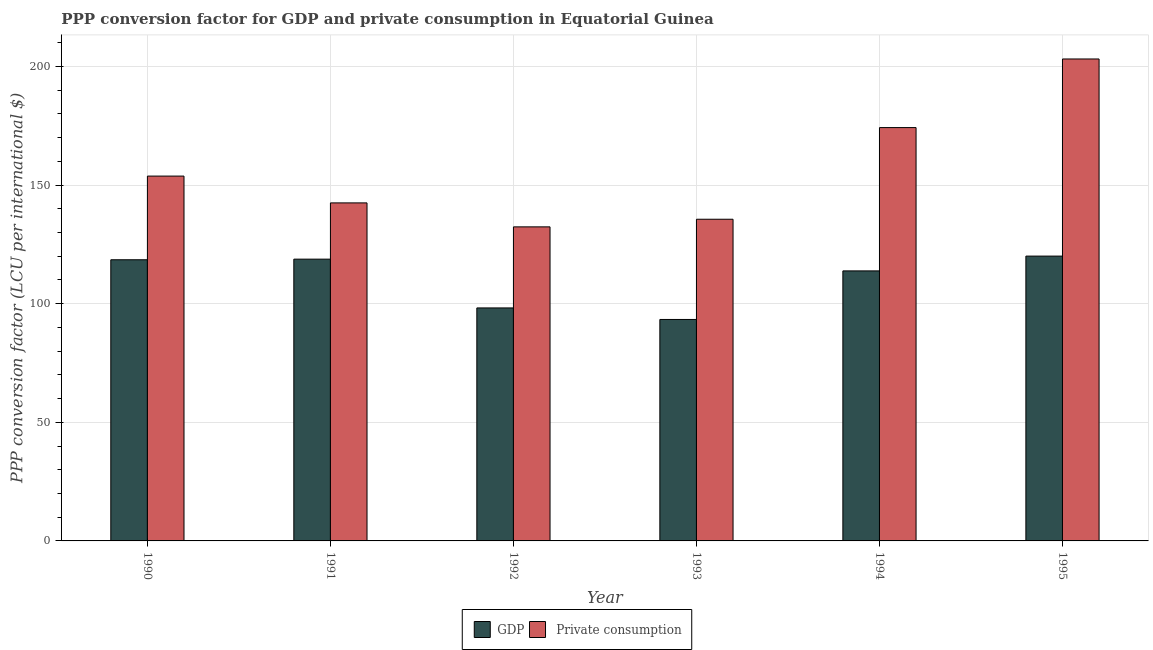How many different coloured bars are there?
Ensure brevity in your answer.  2. How many groups of bars are there?
Provide a short and direct response. 6. Are the number of bars per tick equal to the number of legend labels?
Ensure brevity in your answer.  Yes. How many bars are there on the 2nd tick from the right?
Provide a succinct answer. 2. What is the label of the 4th group of bars from the left?
Provide a succinct answer. 1993. What is the ppp conversion factor for gdp in 1992?
Make the answer very short. 98.22. Across all years, what is the maximum ppp conversion factor for gdp?
Keep it short and to the point. 120.06. Across all years, what is the minimum ppp conversion factor for gdp?
Your response must be concise. 93.35. What is the total ppp conversion factor for gdp in the graph?
Give a very brief answer. 662.74. What is the difference between the ppp conversion factor for private consumption in 1991 and that in 1992?
Provide a succinct answer. 10.11. What is the difference between the ppp conversion factor for private consumption in 1990 and the ppp conversion factor for gdp in 1991?
Your answer should be compact. 11.3. What is the average ppp conversion factor for private consumption per year?
Offer a very short reply. 156.94. In the year 1994, what is the difference between the ppp conversion factor for private consumption and ppp conversion factor for gdp?
Ensure brevity in your answer.  0. What is the ratio of the ppp conversion factor for private consumption in 1990 to that in 1992?
Keep it short and to the point. 1.16. What is the difference between the highest and the second highest ppp conversion factor for gdp?
Keep it short and to the point. 1.29. What is the difference between the highest and the lowest ppp conversion factor for gdp?
Make the answer very short. 26.71. What does the 1st bar from the left in 1992 represents?
Offer a very short reply. GDP. What does the 2nd bar from the right in 1990 represents?
Give a very brief answer. GDP. What is the difference between two consecutive major ticks on the Y-axis?
Offer a very short reply. 50. How many legend labels are there?
Offer a very short reply. 2. How are the legend labels stacked?
Provide a succinct answer. Horizontal. What is the title of the graph?
Provide a short and direct response. PPP conversion factor for GDP and private consumption in Equatorial Guinea. What is the label or title of the Y-axis?
Offer a terse response. PPP conversion factor (LCU per international $). What is the PPP conversion factor (LCU per international $) in GDP in 1990?
Give a very brief answer. 118.52. What is the PPP conversion factor (LCU per international $) in  Private consumption in 1990?
Offer a very short reply. 153.79. What is the PPP conversion factor (LCU per international $) in GDP in 1991?
Make the answer very short. 118.77. What is the PPP conversion factor (LCU per international $) in  Private consumption in 1991?
Your response must be concise. 142.49. What is the PPP conversion factor (LCU per international $) of GDP in 1992?
Offer a terse response. 98.22. What is the PPP conversion factor (LCU per international $) of  Private consumption in 1992?
Offer a very short reply. 132.38. What is the PPP conversion factor (LCU per international $) in GDP in 1993?
Your answer should be compact. 93.35. What is the PPP conversion factor (LCU per international $) of  Private consumption in 1993?
Provide a short and direct response. 135.6. What is the PPP conversion factor (LCU per international $) in GDP in 1994?
Keep it short and to the point. 113.82. What is the PPP conversion factor (LCU per international $) in  Private consumption in 1994?
Keep it short and to the point. 174.23. What is the PPP conversion factor (LCU per international $) of GDP in 1995?
Your answer should be very brief. 120.06. What is the PPP conversion factor (LCU per international $) in  Private consumption in 1995?
Provide a succinct answer. 203.16. Across all years, what is the maximum PPP conversion factor (LCU per international $) of GDP?
Your response must be concise. 120.06. Across all years, what is the maximum PPP conversion factor (LCU per international $) in  Private consumption?
Keep it short and to the point. 203.16. Across all years, what is the minimum PPP conversion factor (LCU per international $) of GDP?
Your response must be concise. 93.35. Across all years, what is the minimum PPP conversion factor (LCU per international $) of  Private consumption?
Provide a short and direct response. 132.38. What is the total PPP conversion factor (LCU per international $) in GDP in the graph?
Offer a very short reply. 662.74. What is the total PPP conversion factor (LCU per international $) of  Private consumption in the graph?
Give a very brief answer. 941.65. What is the difference between the PPP conversion factor (LCU per international $) in GDP in 1990 and that in 1991?
Make the answer very short. -0.26. What is the difference between the PPP conversion factor (LCU per international $) of  Private consumption in 1990 and that in 1991?
Provide a short and direct response. 11.3. What is the difference between the PPP conversion factor (LCU per international $) of GDP in 1990 and that in 1992?
Offer a very short reply. 20.3. What is the difference between the PPP conversion factor (LCU per international $) of  Private consumption in 1990 and that in 1992?
Provide a short and direct response. 21.41. What is the difference between the PPP conversion factor (LCU per international $) in GDP in 1990 and that in 1993?
Your answer should be compact. 25.17. What is the difference between the PPP conversion factor (LCU per international $) of  Private consumption in 1990 and that in 1993?
Your answer should be very brief. 18.19. What is the difference between the PPP conversion factor (LCU per international $) of GDP in 1990 and that in 1994?
Your answer should be compact. 4.69. What is the difference between the PPP conversion factor (LCU per international $) of  Private consumption in 1990 and that in 1994?
Give a very brief answer. -20.44. What is the difference between the PPP conversion factor (LCU per international $) of GDP in 1990 and that in 1995?
Your answer should be compact. -1.54. What is the difference between the PPP conversion factor (LCU per international $) in  Private consumption in 1990 and that in 1995?
Ensure brevity in your answer.  -49.36. What is the difference between the PPP conversion factor (LCU per international $) of GDP in 1991 and that in 1992?
Your answer should be compact. 20.56. What is the difference between the PPP conversion factor (LCU per international $) in  Private consumption in 1991 and that in 1992?
Give a very brief answer. 10.11. What is the difference between the PPP conversion factor (LCU per international $) of GDP in 1991 and that in 1993?
Your answer should be very brief. 25.42. What is the difference between the PPP conversion factor (LCU per international $) in  Private consumption in 1991 and that in 1993?
Your response must be concise. 6.89. What is the difference between the PPP conversion factor (LCU per international $) in GDP in 1991 and that in 1994?
Provide a short and direct response. 4.95. What is the difference between the PPP conversion factor (LCU per international $) in  Private consumption in 1991 and that in 1994?
Provide a short and direct response. -31.74. What is the difference between the PPP conversion factor (LCU per international $) in GDP in 1991 and that in 1995?
Ensure brevity in your answer.  -1.29. What is the difference between the PPP conversion factor (LCU per international $) of  Private consumption in 1991 and that in 1995?
Your answer should be compact. -60.67. What is the difference between the PPP conversion factor (LCU per international $) of GDP in 1992 and that in 1993?
Your response must be concise. 4.87. What is the difference between the PPP conversion factor (LCU per international $) in  Private consumption in 1992 and that in 1993?
Make the answer very short. -3.22. What is the difference between the PPP conversion factor (LCU per international $) of GDP in 1992 and that in 1994?
Offer a very short reply. -15.61. What is the difference between the PPP conversion factor (LCU per international $) in  Private consumption in 1992 and that in 1994?
Your answer should be very brief. -41.85. What is the difference between the PPP conversion factor (LCU per international $) in GDP in 1992 and that in 1995?
Make the answer very short. -21.85. What is the difference between the PPP conversion factor (LCU per international $) of  Private consumption in 1992 and that in 1995?
Give a very brief answer. -70.77. What is the difference between the PPP conversion factor (LCU per international $) in GDP in 1993 and that in 1994?
Keep it short and to the point. -20.47. What is the difference between the PPP conversion factor (LCU per international $) in  Private consumption in 1993 and that in 1994?
Give a very brief answer. -38.63. What is the difference between the PPP conversion factor (LCU per international $) of GDP in 1993 and that in 1995?
Provide a succinct answer. -26.71. What is the difference between the PPP conversion factor (LCU per international $) of  Private consumption in 1993 and that in 1995?
Offer a very short reply. -67.56. What is the difference between the PPP conversion factor (LCU per international $) of GDP in 1994 and that in 1995?
Ensure brevity in your answer.  -6.24. What is the difference between the PPP conversion factor (LCU per international $) of  Private consumption in 1994 and that in 1995?
Your answer should be compact. -28.92. What is the difference between the PPP conversion factor (LCU per international $) in GDP in 1990 and the PPP conversion factor (LCU per international $) in  Private consumption in 1991?
Your answer should be very brief. -23.97. What is the difference between the PPP conversion factor (LCU per international $) of GDP in 1990 and the PPP conversion factor (LCU per international $) of  Private consumption in 1992?
Offer a terse response. -13.87. What is the difference between the PPP conversion factor (LCU per international $) of GDP in 1990 and the PPP conversion factor (LCU per international $) of  Private consumption in 1993?
Your response must be concise. -17.08. What is the difference between the PPP conversion factor (LCU per international $) of GDP in 1990 and the PPP conversion factor (LCU per international $) of  Private consumption in 1994?
Offer a very short reply. -55.71. What is the difference between the PPP conversion factor (LCU per international $) in GDP in 1990 and the PPP conversion factor (LCU per international $) in  Private consumption in 1995?
Your response must be concise. -84.64. What is the difference between the PPP conversion factor (LCU per international $) in GDP in 1991 and the PPP conversion factor (LCU per international $) in  Private consumption in 1992?
Your answer should be compact. -13.61. What is the difference between the PPP conversion factor (LCU per international $) of GDP in 1991 and the PPP conversion factor (LCU per international $) of  Private consumption in 1993?
Your answer should be compact. -16.82. What is the difference between the PPP conversion factor (LCU per international $) in GDP in 1991 and the PPP conversion factor (LCU per international $) in  Private consumption in 1994?
Your answer should be compact. -55.46. What is the difference between the PPP conversion factor (LCU per international $) in GDP in 1991 and the PPP conversion factor (LCU per international $) in  Private consumption in 1995?
Your response must be concise. -84.38. What is the difference between the PPP conversion factor (LCU per international $) of GDP in 1992 and the PPP conversion factor (LCU per international $) of  Private consumption in 1993?
Offer a terse response. -37.38. What is the difference between the PPP conversion factor (LCU per international $) in GDP in 1992 and the PPP conversion factor (LCU per international $) in  Private consumption in 1994?
Offer a terse response. -76.02. What is the difference between the PPP conversion factor (LCU per international $) of GDP in 1992 and the PPP conversion factor (LCU per international $) of  Private consumption in 1995?
Offer a terse response. -104.94. What is the difference between the PPP conversion factor (LCU per international $) in GDP in 1993 and the PPP conversion factor (LCU per international $) in  Private consumption in 1994?
Make the answer very short. -80.88. What is the difference between the PPP conversion factor (LCU per international $) of GDP in 1993 and the PPP conversion factor (LCU per international $) of  Private consumption in 1995?
Offer a very short reply. -109.81. What is the difference between the PPP conversion factor (LCU per international $) of GDP in 1994 and the PPP conversion factor (LCU per international $) of  Private consumption in 1995?
Your answer should be very brief. -89.33. What is the average PPP conversion factor (LCU per international $) of GDP per year?
Make the answer very short. 110.46. What is the average PPP conversion factor (LCU per international $) in  Private consumption per year?
Give a very brief answer. 156.94. In the year 1990, what is the difference between the PPP conversion factor (LCU per international $) in GDP and PPP conversion factor (LCU per international $) in  Private consumption?
Offer a very short reply. -35.27. In the year 1991, what is the difference between the PPP conversion factor (LCU per international $) of GDP and PPP conversion factor (LCU per international $) of  Private consumption?
Make the answer very short. -23.72. In the year 1992, what is the difference between the PPP conversion factor (LCU per international $) of GDP and PPP conversion factor (LCU per international $) of  Private consumption?
Offer a very short reply. -34.17. In the year 1993, what is the difference between the PPP conversion factor (LCU per international $) in GDP and PPP conversion factor (LCU per international $) in  Private consumption?
Provide a succinct answer. -42.25. In the year 1994, what is the difference between the PPP conversion factor (LCU per international $) of GDP and PPP conversion factor (LCU per international $) of  Private consumption?
Ensure brevity in your answer.  -60.41. In the year 1995, what is the difference between the PPP conversion factor (LCU per international $) in GDP and PPP conversion factor (LCU per international $) in  Private consumption?
Your answer should be compact. -83.1. What is the ratio of the PPP conversion factor (LCU per international $) in  Private consumption in 1990 to that in 1991?
Your answer should be very brief. 1.08. What is the ratio of the PPP conversion factor (LCU per international $) of GDP in 1990 to that in 1992?
Give a very brief answer. 1.21. What is the ratio of the PPP conversion factor (LCU per international $) of  Private consumption in 1990 to that in 1992?
Keep it short and to the point. 1.16. What is the ratio of the PPP conversion factor (LCU per international $) in GDP in 1990 to that in 1993?
Provide a succinct answer. 1.27. What is the ratio of the PPP conversion factor (LCU per international $) in  Private consumption in 1990 to that in 1993?
Provide a short and direct response. 1.13. What is the ratio of the PPP conversion factor (LCU per international $) in GDP in 1990 to that in 1994?
Your response must be concise. 1.04. What is the ratio of the PPP conversion factor (LCU per international $) of  Private consumption in 1990 to that in 1994?
Offer a very short reply. 0.88. What is the ratio of the PPP conversion factor (LCU per international $) of GDP in 1990 to that in 1995?
Give a very brief answer. 0.99. What is the ratio of the PPP conversion factor (LCU per international $) of  Private consumption in 1990 to that in 1995?
Offer a very short reply. 0.76. What is the ratio of the PPP conversion factor (LCU per international $) in GDP in 1991 to that in 1992?
Give a very brief answer. 1.21. What is the ratio of the PPP conversion factor (LCU per international $) in  Private consumption in 1991 to that in 1992?
Provide a short and direct response. 1.08. What is the ratio of the PPP conversion factor (LCU per international $) of GDP in 1991 to that in 1993?
Provide a succinct answer. 1.27. What is the ratio of the PPP conversion factor (LCU per international $) in  Private consumption in 1991 to that in 1993?
Your answer should be compact. 1.05. What is the ratio of the PPP conversion factor (LCU per international $) of GDP in 1991 to that in 1994?
Ensure brevity in your answer.  1.04. What is the ratio of the PPP conversion factor (LCU per international $) in  Private consumption in 1991 to that in 1994?
Keep it short and to the point. 0.82. What is the ratio of the PPP conversion factor (LCU per international $) of GDP in 1991 to that in 1995?
Your response must be concise. 0.99. What is the ratio of the PPP conversion factor (LCU per international $) in  Private consumption in 1991 to that in 1995?
Your response must be concise. 0.7. What is the ratio of the PPP conversion factor (LCU per international $) in GDP in 1992 to that in 1993?
Offer a very short reply. 1.05. What is the ratio of the PPP conversion factor (LCU per international $) of  Private consumption in 1992 to that in 1993?
Give a very brief answer. 0.98. What is the ratio of the PPP conversion factor (LCU per international $) of GDP in 1992 to that in 1994?
Your answer should be very brief. 0.86. What is the ratio of the PPP conversion factor (LCU per international $) in  Private consumption in 1992 to that in 1994?
Offer a very short reply. 0.76. What is the ratio of the PPP conversion factor (LCU per international $) of GDP in 1992 to that in 1995?
Make the answer very short. 0.82. What is the ratio of the PPP conversion factor (LCU per international $) of  Private consumption in 1992 to that in 1995?
Make the answer very short. 0.65. What is the ratio of the PPP conversion factor (LCU per international $) of GDP in 1993 to that in 1994?
Keep it short and to the point. 0.82. What is the ratio of the PPP conversion factor (LCU per international $) of  Private consumption in 1993 to that in 1994?
Ensure brevity in your answer.  0.78. What is the ratio of the PPP conversion factor (LCU per international $) of GDP in 1993 to that in 1995?
Provide a short and direct response. 0.78. What is the ratio of the PPP conversion factor (LCU per international $) in  Private consumption in 1993 to that in 1995?
Ensure brevity in your answer.  0.67. What is the ratio of the PPP conversion factor (LCU per international $) of GDP in 1994 to that in 1995?
Give a very brief answer. 0.95. What is the ratio of the PPP conversion factor (LCU per international $) of  Private consumption in 1994 to that in 1995?
Give a very brief answer. 0.86. What is the difference between the highest and the second highest PPP conversion factor (LCU per international $) of GDP?
Offer a terse response. 1.29. What is the difference between the highest and the second highest PPP conversion factor (LCU per international $) in  Private consumption?
Provide a short and direct response. 28.92. What is the difference between the highest and the lowest PPP conversion factor (LCU per international $) in GDP?
Offer a terse response. 26.71. What is the difference between the highest and the lowest PPP conversion factor (LCU per international $) of  Private consumption?
Provide a short and direct response. 70.77. 